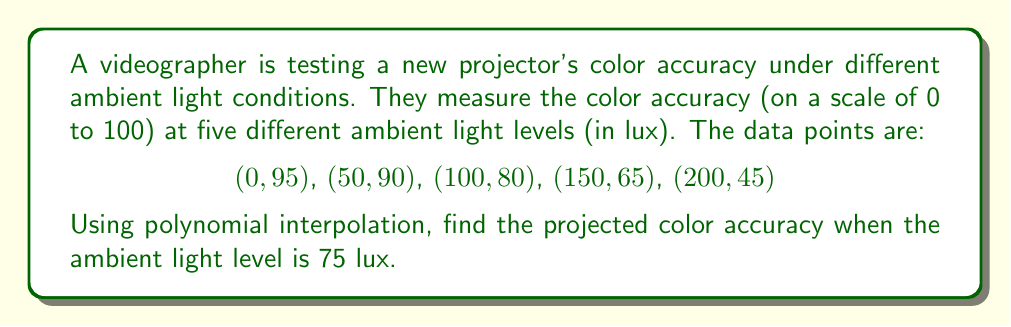Show me your answer to this math problem. To solve this problem, we'll use Lagrange polynomial interpolation:

1) The Lagrange polynomial is given by:
   $$L(x) = \sum_{i=1}^n y_i \cdot \prod_{j \neq i} \frac{x - x_j}{x_i - x_j}$$

2) For our data points:
   $n = 5$
   $(x_1, y_1) = (0, 95)$
   $(x_2, y_2) = (50, 90)$
   $(x_3, y_3) = (100, 80)$
   $(x_4, y_4) = (150, 65)$
   $(x_5, y_5) = (200, 45)$

3) We need to calculate $L(75)$. Let's break it down term by term:

   $$L(75) = 95 \cdot \frac{(75-50)(75-100)(75-150)(75-200)}{(0-50)(0-100)(0-150)(0-200)} +$$
   $$90 \cdot \frac{(75-0)(75-100)(75-150)(75-200)}{(50-0)(50-100)(50-150)(50-200)} +$$
   $$80 \cdot \frac{(75-0)(75-50)(75-150)(75-200)}{(100-0)(100-50)(100-150)(100-200)} +$$
   $$65 \cdot \frac{(75-0)(75-50)(75-100)(75-200)}{(150-0)(150-50)(150-100)(150-200)} +$$
   $$45 \cdot \frac{(75-0)(75-50)(75-100)(75-150)}{(200-0)(200-50)(200-100)(200-150)}$$

4) Calculating each term:
   Term 1 ≈ 11.7188
   Term 2 ≈ 48.7500
   Term 3 ≈ 26.2500
   Term 4 ≈ -1.6875
   Term 5 ≈ 0.0938

5) Sum all terms:
   $L(75) ≈ 11.7188 + 48.7500 + 26.2500 - 1.6875 + 0.0938 = 85.1251$

Therefore, the projected color accuracy at 75 lux is approximately 85.13 (rounded to two decimal places).
Answer: 85.13 